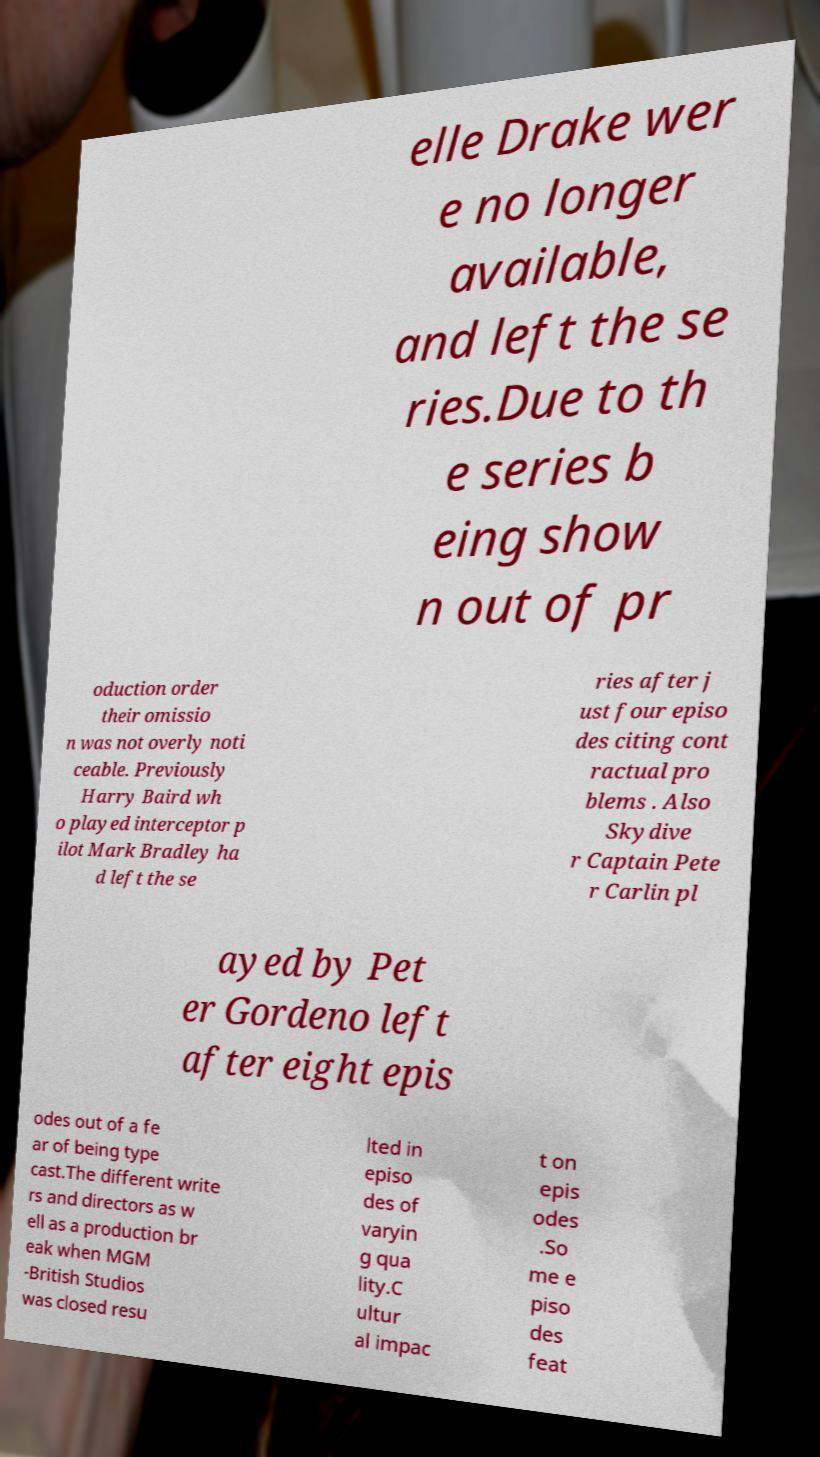What messages or text are displayed in this image? I need them in a readable, typed format. elle Drake wer e no longer available, and left the se ries.Due to th e series b eing show n out of pr oduction order their omissio n was not overly noti ceable. Previously Harry Baird wh o played interceptor p ilot Mark Bradley ha d left the se ries after j ust four episo des citing cont ractual pro blems . Also Skydive r Captain Pete r Carlin pl ayed by Pet er Gordeno left after eight epis odes out of a fe ar of being type cast.The different write rs and directors as w ell as a production br eak when MGM -British Studios was closed resu lted in episo des of varyin g qua lity.C ultur al impac t on epis odes .So me e piso des feat 